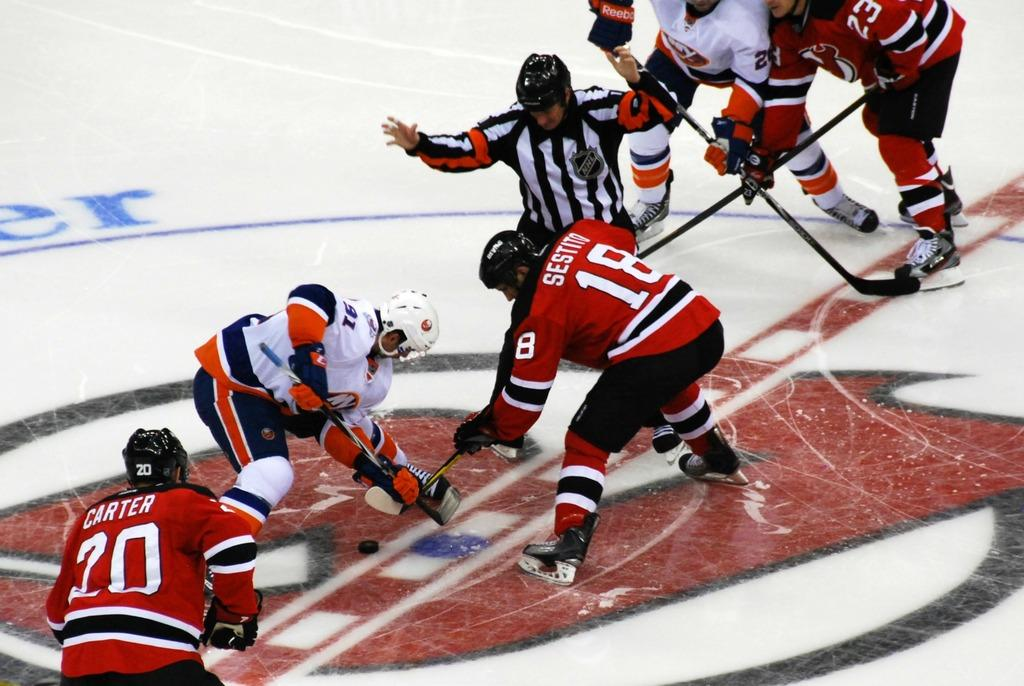How many people are in the image? There is a group of people in the image, but the exact number is not specified. What are the people doing in the image? The people are on the ground and holding sticks. Can you describe the position or arrangement of the people in the image? The provided facts do not give enough information to describe the position or arrangement of the people. What type of zinc is being used by the people in the image? There is no mention of zinc in the image, so it cannot be determined if it is being used by the people. Who is the creator of the image? The provided facts do not give any information about the creator of the image. 